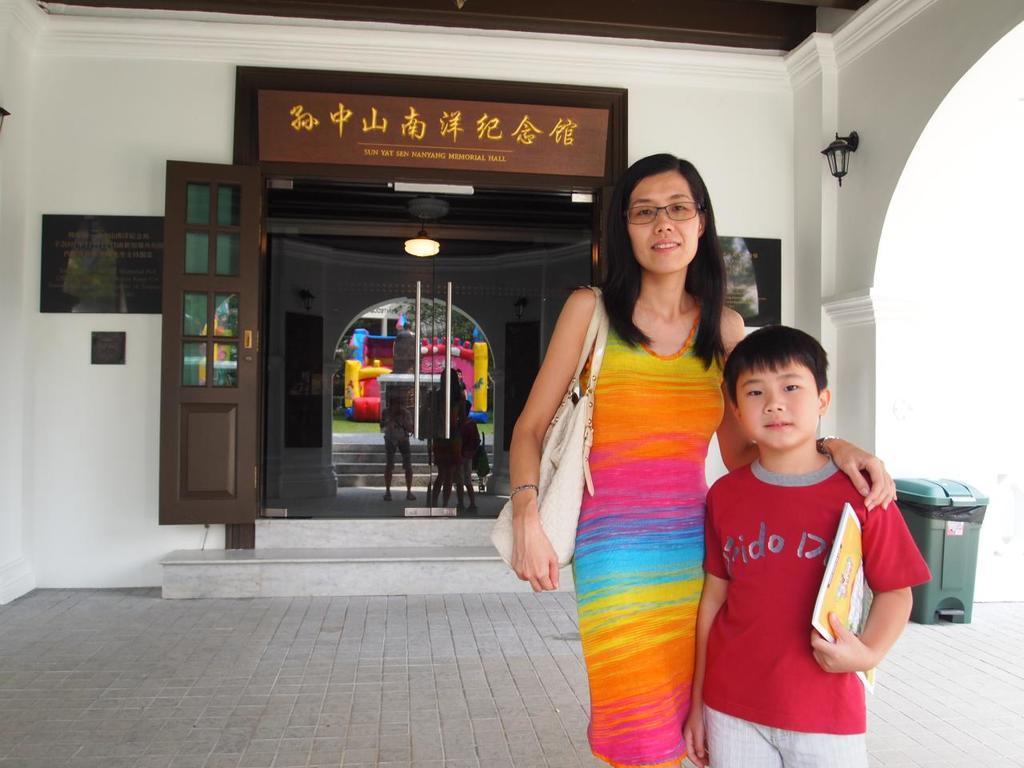Can you describe this image briefly? In this image I can see the building with boards and the glass. To the right I can see the dustbin. Through the glass I can see the lights, inflatable and the trees. 